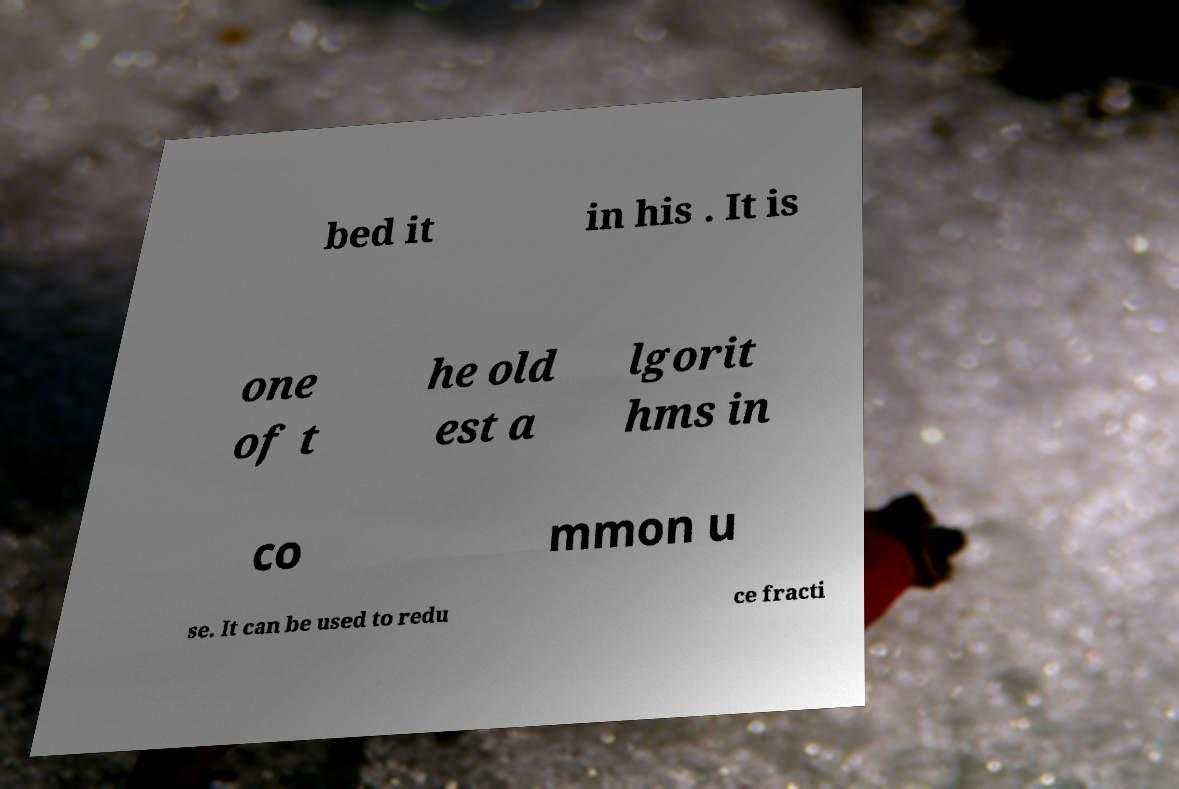There's text embedded in this image that I need extracted. Can you transcribe it verbatim? bed it in his . It is one of t he old est a lgorit hms in co mmon u se. It can be used to redu ce fracti 